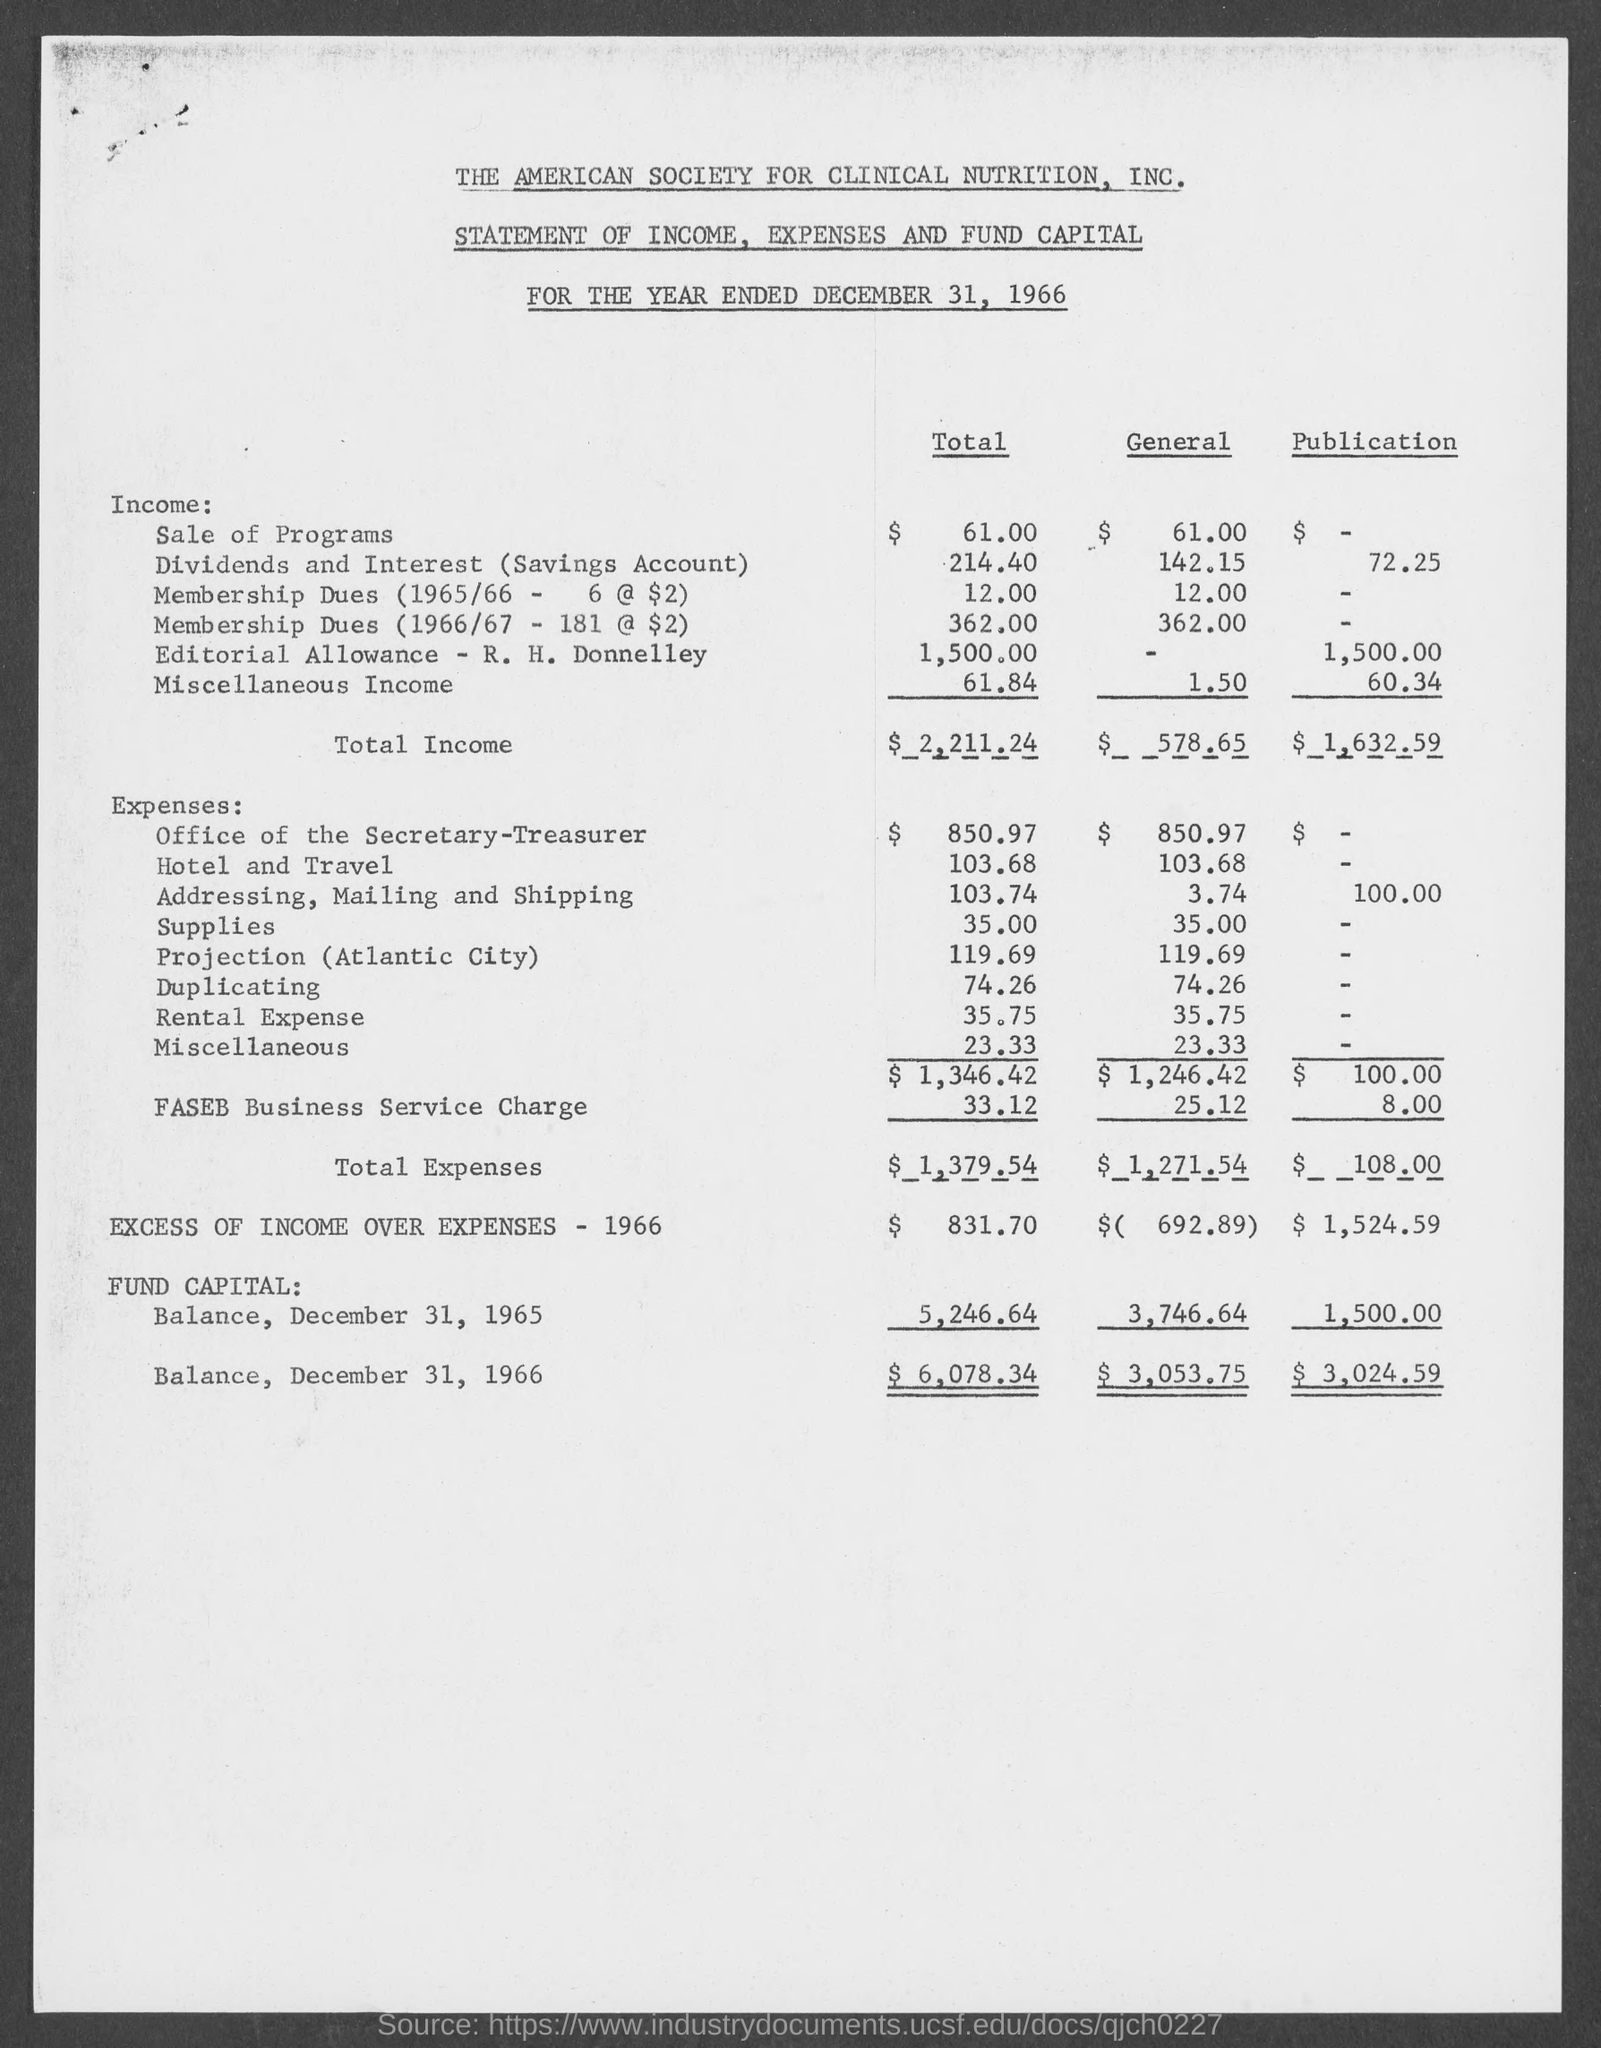What is the total income in total ?
Your response must be concise. $2,211.24. What is the total income in general ?
Your answer should be very brief. $ 578.65. What is the total income in publication ?
Your answer should be very brief. $ 1,632.59. What is the total expenses in total?
Offer a terse response. $1,379.54. What is the total expense in general?
Provide a succinct answer. $1,271.54. What is the total expenses in publication ?
Keep it short and to the point. $108.00. What is the fund capital balance, december 31, 1965 in total?
Offer a very short reply. $5,246.64. What is the fund capital balance, december 31, 1966 in total?
Your answer should be compact. $6,078.34. What is the fund capital balance, december 31, 1965 in general?
Make the answer very short. 3,746.64. What is the fund capital balance, december 31, 1966 in general?
Make the answer very short. $3,053.75. 